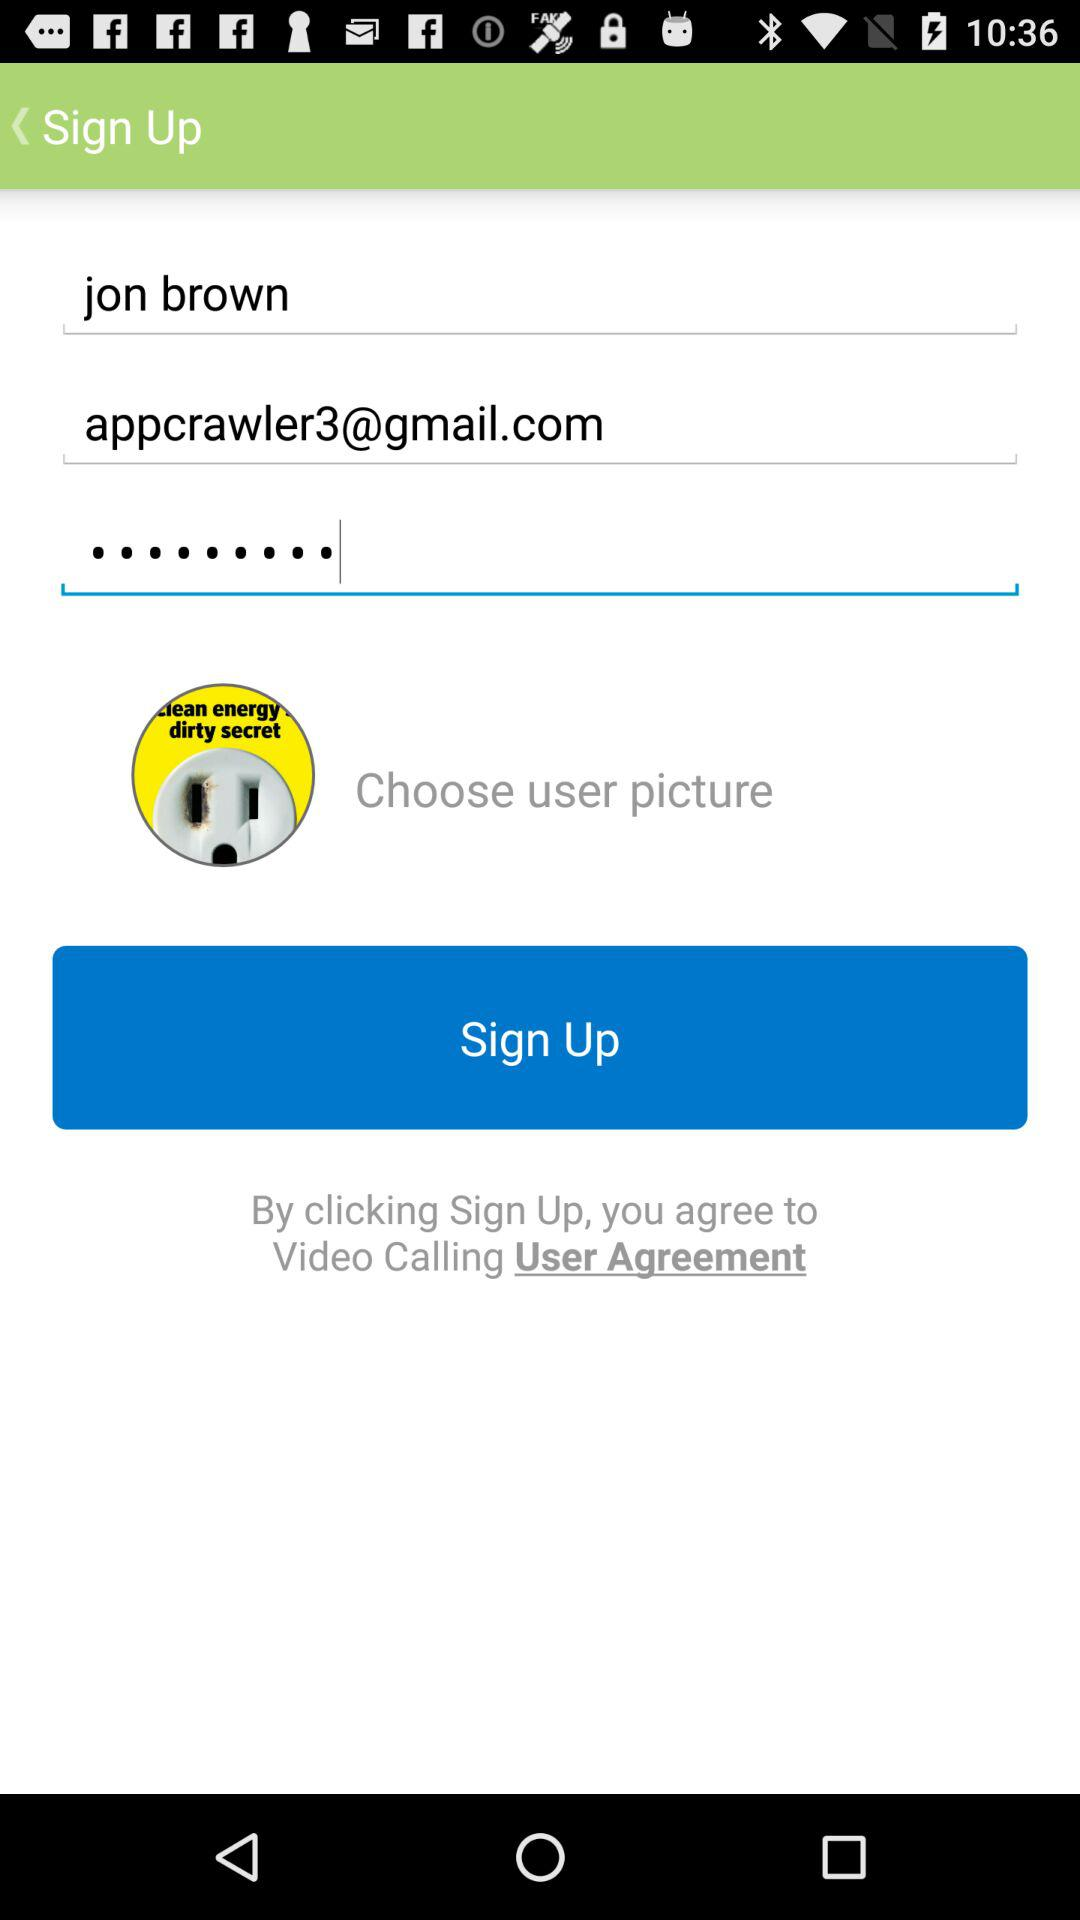How many text inputs are required to sign up?
Answer the question using a single word or phrase. 3 